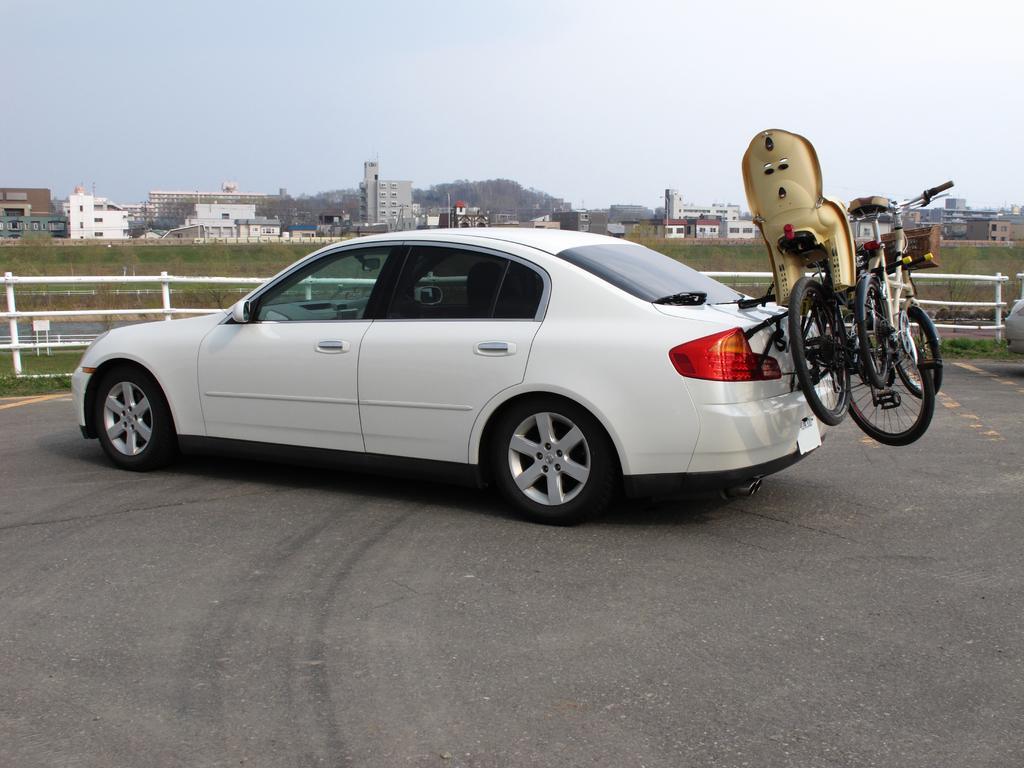In one or two sentences, can you explain what this image depicts? In this picture I can see bicycles attached to backside of a car. In the background I can see few buildings and trees. 